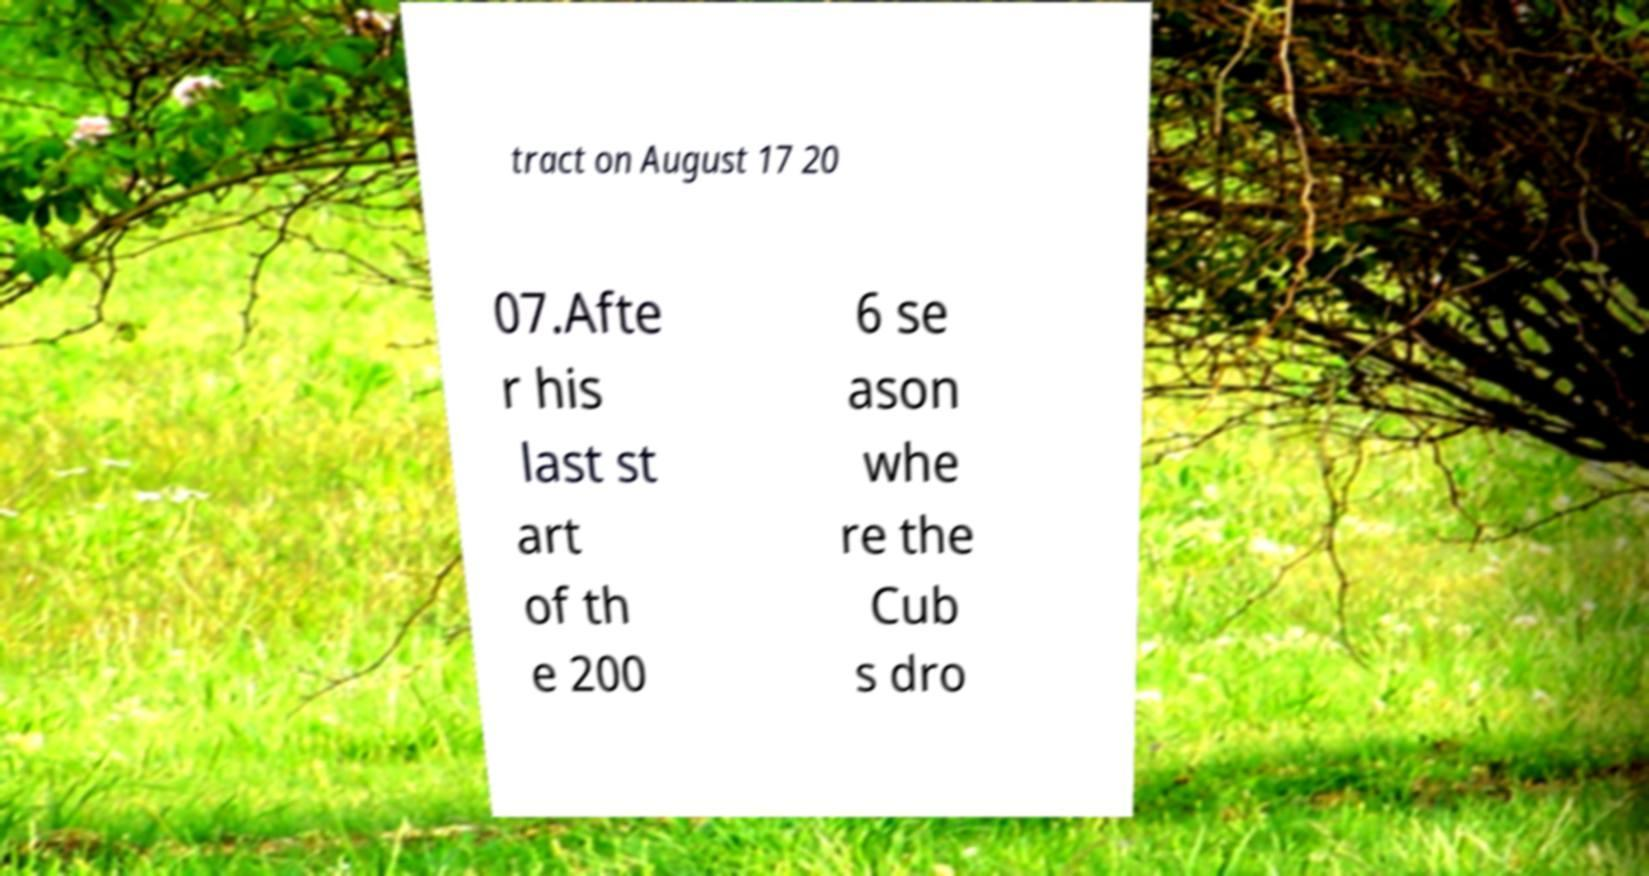For documentation purposes, I need the text within this image transcribed. Could you provide that? tract on August 17 20 07.Afte r his last st art of th e 200 6 se ason whe re the Cub s dro 